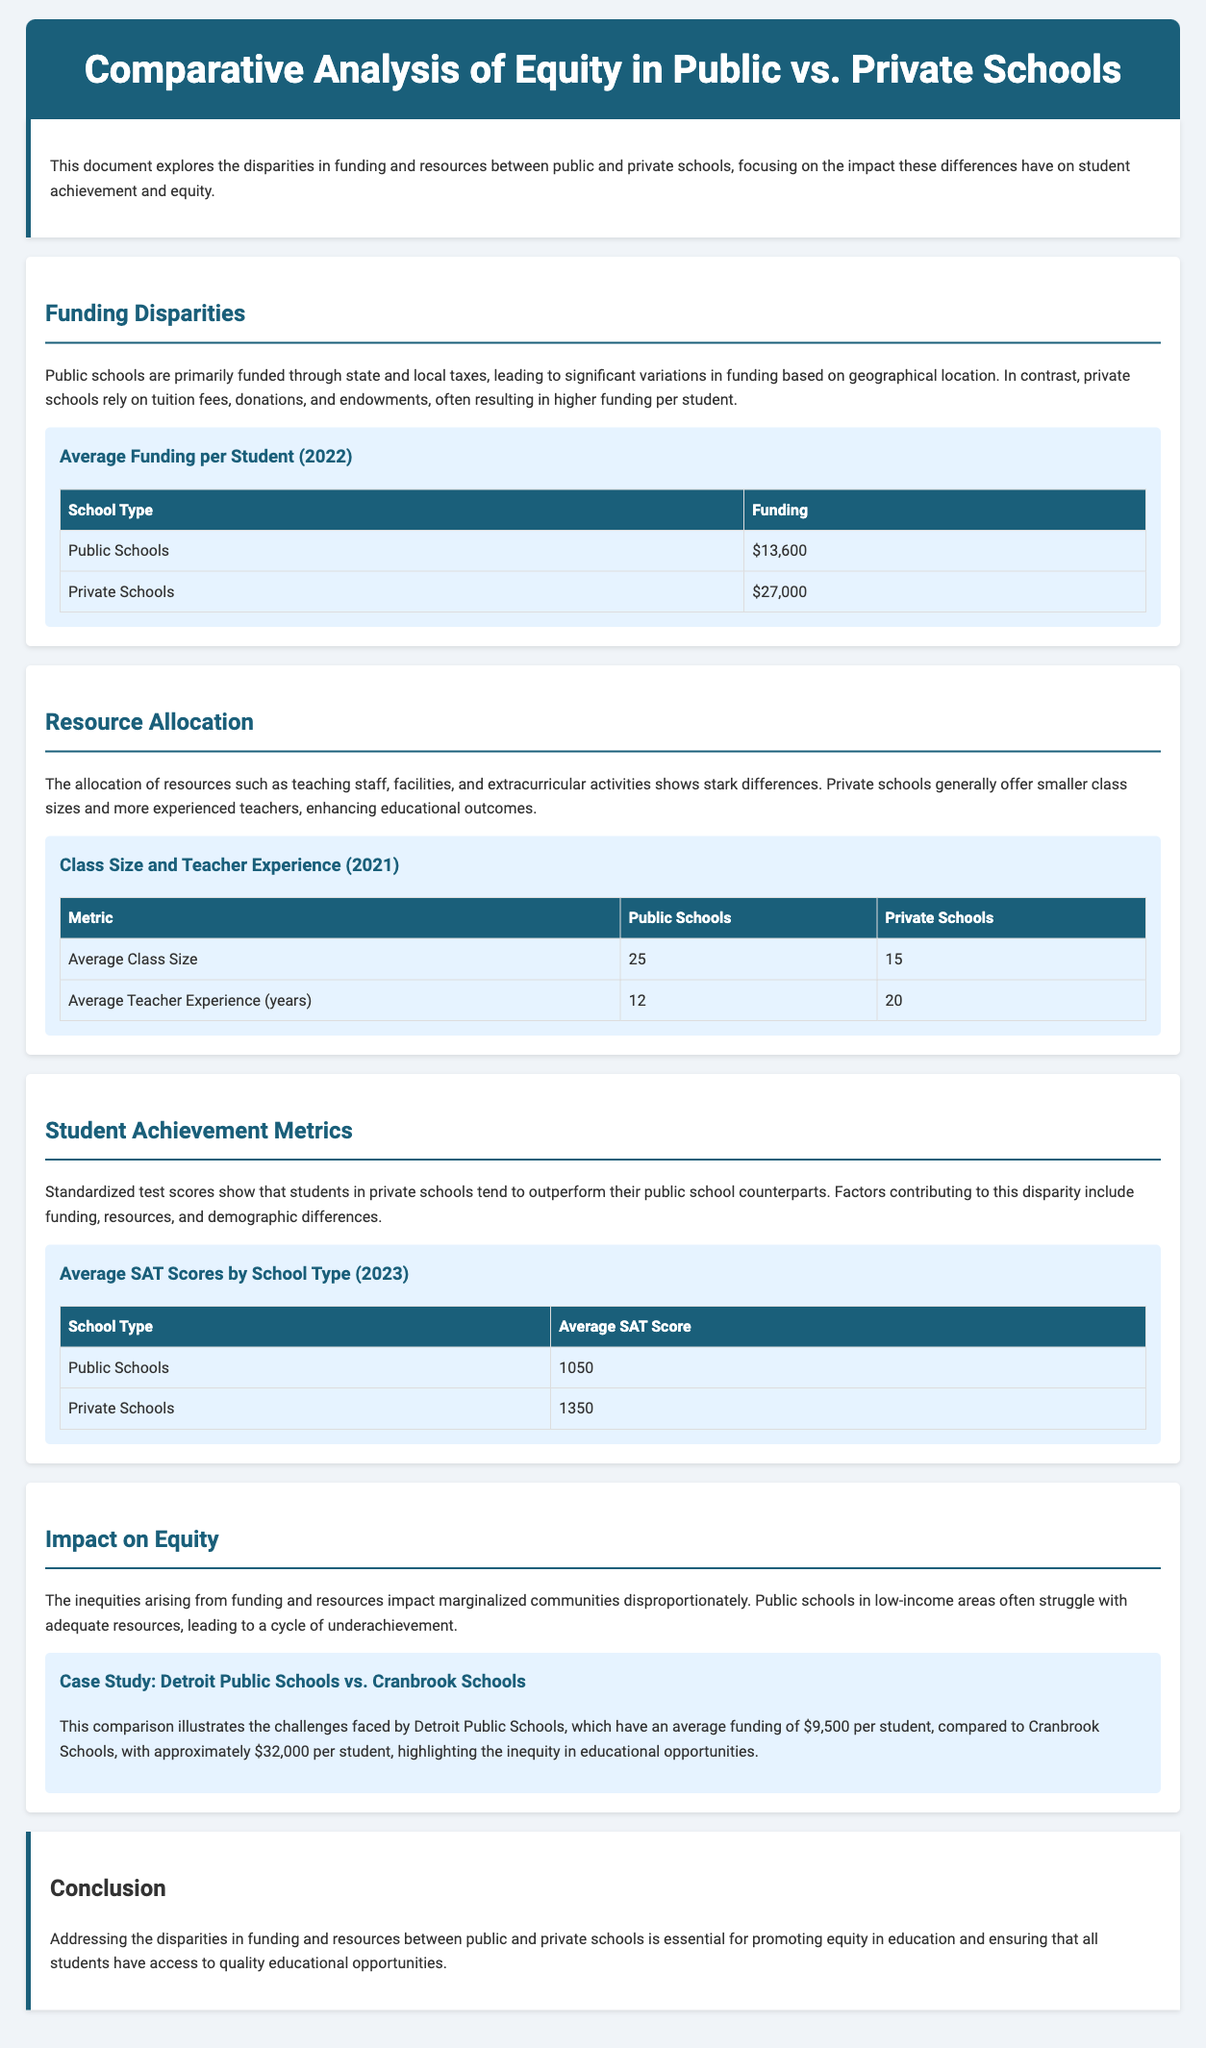what is the average funding per student for public schools? The document states that the average funding for public schools is $13,600.
Answer: $13,600 what is the average SAT score for private schools? According to the document, private schools have an average SAT score of 1350.
Answer: 1350 what is the average class size in private schools? The document indicates that the average class size in private schools is 15.
Answer: 15 how many years of teacher experience do public schools have on average? The document mentions that public schools have an average teacher experience of 12 years.
Answer: 12 what is the average funding per student for Detroit Public Schools? The average funding for Detroit Public Schools is reported as $9,500 per student.
Answer: $9,500 what is the average funding per student for Cranbrook Schools? The document states that Cranbrook Schools have approximately $32,000 per student in funding.
Answer: $32,000 what year is referenced for the average SAT scores in the document? The document references the year 2023 for the average SAT scores.
Answer: 2023 what are the primary funding sources for public schools? The primary funding sources for public schools are state and local taxes.
Answer: state and local taxes what is the impact of funding disparities on marginalized communities? The document explains that funding disparities disproportionately impact marginalized communities.
Answer: disproportionately impact marginalized communities 